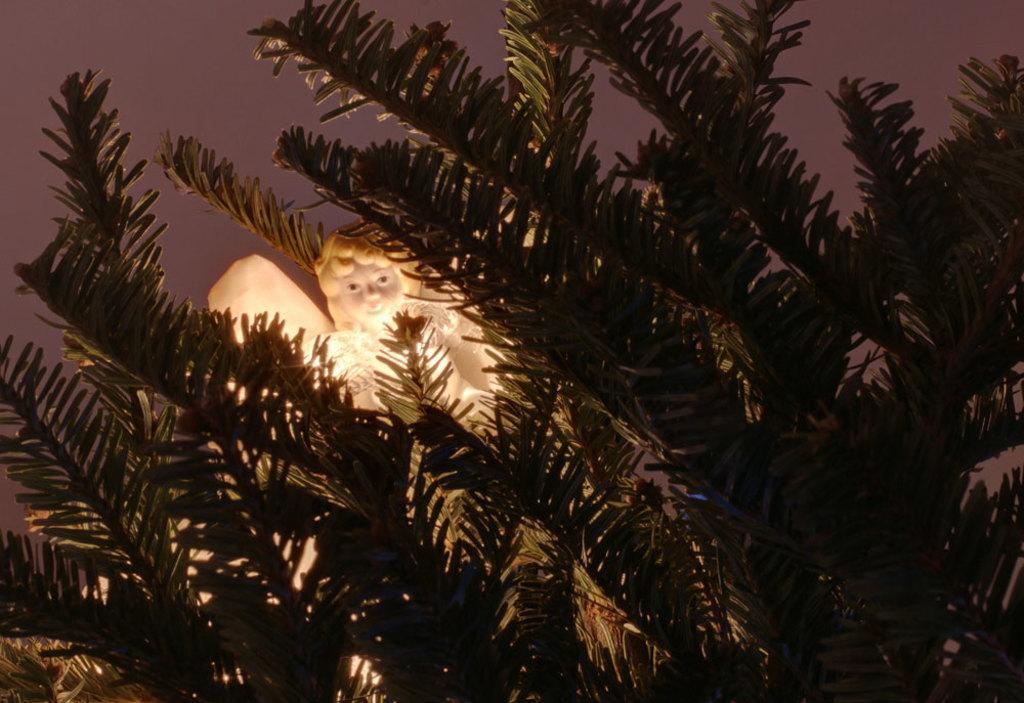Please provide a concise description of this image. There is a statue of a girl with wings in between the trees and in the background we can observe a sky here. 